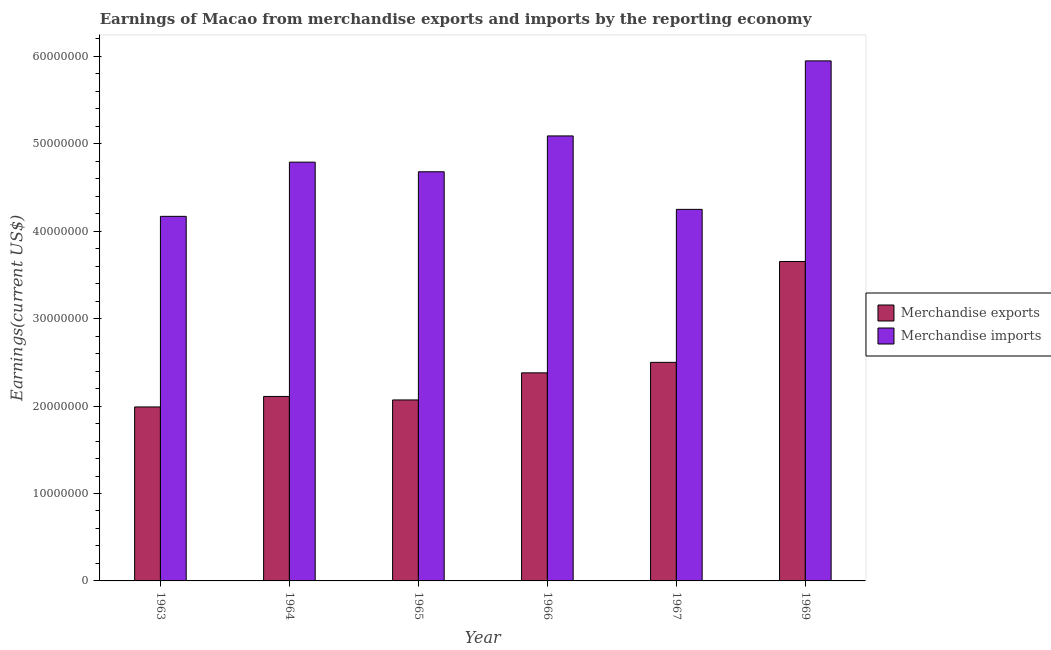How many different coloured bars are there?
Your answer should be compact. 2. How many groups of bars are there?
Offer a very short reply. 6. Are the number of bars on each tick of the X-axis equal?
Keep it short and to the point. Yes. How many bars are there on the 5th tick from the left?
Give a very brief answer. 2. What is the earnings from merchandise exports in 1964?
Your answer should be very brief. 2.11e+07. Across all years, what is the maximum earnings from merchandise exports?
Your answer should be very brief. 3.65e+07. Across all years, what is the minimum earnings from merchandise imports?
Provide a succinct answer. 4.17e+07. In which year was the earnings from merchandise exports maximum?
Give a very brief answer. 1969. In which year was the earnings from merchandise exports minimum?
Make the answer very short. 1963. What is the total earnings from merchandise exports in the graph?
Your answer should be very brief. 1.47e+08. What is the difference between the earnings from merchandise exports in 1966 and that in 1969?
Your answer should be very brief. -1.27e+07. What is the difference between the earnings from merchandise exports in 1969 and the earnings from merchandise imports in 1966?
Offer a terse response. 1.27e+07. What is the average earnings from merchandise exports per year?
Keep it short and to the point. 2.45e+07. In the year 1969, what is the difference between the earnings from merchandise imports and earnings from merchandise exports?
Your answer should be very brief. 0. In how many years, is the earnings from merchandise imports greater than 56000000 US$?
Ensure brevity in your answer.  1. What is the ratio of the earnings from merchandise imports in 1964 to that in 1969?
Provide a succinct answer. 0.81. Is the earnings from merchandise exports in 1965 less than that in 1969?
Your answer should be very brief. Yes. What is the difference between the highest and the second highest earnings from merchandise exports?
Keep it short and to the point. 1.15e+07. What is the difference between the highest and the lowest earnings from merchandise imports?
Your answer should be very brief. 1.78e+07. In how many years, is the earnings from merchandise exports greater than the average earnings from merchandise exports taken over all years?
Ensure brevity in your answer.  2. How many bars are there?
Make the answer very short. 12. Are all the bars in the graph horizontal?
Your response must be concise. No. How many years are there in the graph?
Give a very brief answer. 6. Are the values on the major ticks of Y-axis written in scientific E-notation?
Offer a terse response. No. Does the graph contain grids?
Give a very brief answer. No. Where does the legend appear in the graph?
Your response must be concise. Center right. How are the legend labels stacked?
Provide a short and direct response. Vertical. What is the title of the graph?
Ensure brevity in your answer.  Earnings of Macao from merchandise exports and imports by the reporting economy. Does "Time to export" appear as one of the legend labels in the graph?
Your answer should be compact. No. What is the label or title of the Y-axis?
Your answer should be compact. Earnings(current US$). What is the Earnings(current US$) of Merchandise exports in 1963?
Offer a very short reply. 1.99e+07. What is the Earnings(current US$) of Merchandise imports in 1963?
Provide a succinct answer. 4.17e+07. What is the Earnings(current US$) of Merchandise exports in 1964?
Your response must be concise. 2.11e+07. What is the Earnings(current US$) in Merchandise imports in 1964?
Make the answer very short. 4.79e+07. What is the Earnings(current US$) of Merchandise exports in 1965?
Your response must be concise. 2.07e+07. What is the Earnings(current US$) in Merchandise imports in 1965?
Offer a very short reply. 4.68e+07. What is the Earnings(current US$) of Merchandise exports in 1966?
Your response must be concise. 2.38e+07. What is the Earnings(current US$) in Merchandise imports in 1966?
Give a very brief answer. 5.09e+07. What is the Earnings(current US$) in Merchandise exports in 1967?
Keep it short and to the point. 2.50e+07. What is the Earnings(current US$) in Merchandise imports in 1967?
Ensure brevity in your answer.  4.25e+07. What is the Earnings(current US$) of Merchandise exports in 1969?
Provide a succinct answer. 3.65e+07. What is the Earnings(current US$) in Merchandise imports in 1969?
Ensure brevity in your answer.  5.95e+07. Across all years, what is the maximum Earnings(current US$) of Merchandise exports?
Provide a short and direct response. 3.65e+07. Across all years, what is the maximum Earnings(current US$) in Merchandise imports?
Offer a very short reply. 5.95e+07. Across all years, what is the minimum Earnings(current US$) in Merchandise exports?
Your answer should be compact. 1.99e+07. Across all years, what is the minimum Earnings(current US$) in Merchandise imports?
Provide a short and direct response. 4.17e+07. What is the total Earnings(current US$) in Merchandise exports in the graph?
Your response must be concise. 1.47e+08. What is the total Earnings(current US$) in Merchandise imports in the graph?
Give a very brief answer. 2.89e+08. What is the difference between the Earnings(current US$) of Merchandise exports in 1963 and that in 1964?
Ensure brevity in your answer.  -1.20e+06. What is the difference between the Earnings(current US$) in Merchandise imports in 1963 and that in 1964?
Your answer should be very brief. -6.20e+06. What is the difference between the Earnings(current US$) in Merchandise exports in 1963 and that in 1965?
Ensure brevity in your answer.  -8.00e+05. What is the difference between the Earnings(current US$) of Merchandise imports in 1963 and that in 1965?
Provide a short and direct response. -5.10e+06. What is the difference between the Earnings(current US$) of Merchandise exports in 1963 and that in 1966?
Offer a very short reply. -3.90e+06. What is the difference between the Earnings(current US$) of Merchandise imports in 1963 and that in 1966?
Ensure brevity in your answer.  -9.20e+06. What is the difference between the Earnings(current US$) in Merchandise exports in 1963 and that in 1967?
Ensure brevity in your answer.  -5.10e+06. What is the difference between the Earnings(current US$) of Merchandise imports in 1963 and that in 1967?
Your response must be concise. -8.00e+05. What is the difference between the Earnings(current US$) in Merchandise exports in 1963 and that in 1969?
Your answer should be very brief. -1.66e+07. What is the difference between the Earnings(current US$) in Merchandise imports in 1963 and that in 1969?
Offer a very short reply. -1.78e+07. What is the difference between the Earnings(current US$) of Merchandise imports in 1964 and that in 1965?
Provide a short and direct response. 1.10e+06. What is the difference between the Earnings(current US$) in Merchandise exports in 1964 and that in 1966?
Your answer should be compact. -2.70e+06. What is the difference between the Earnings(current US$) in Merchandise exports in 1964 and that in 1967?
Keep it short and to the point. -3.90e+06. What is the difference between the Earnings(current US$) in Merchandise imports in 1964 and that in 1967?
Your answer should be very brief. 5.40e+06. What is the difference between the Earnings(current US$) of Merchandise exports in 1964 and that in 1969?
Provide a succinct answer. -1.54e+07. What is the difference between the Earnings(current US$) in Merchandise imports in 1964 and that in 1969?
Your answer should be compact. -1.16e+07. What is the difference between the Earnings(current US$) of Merchandise exports in 1965 and that in 1966?
Your response must be concise. -3.10e+06. What is the difference between the Earnings(current US$) of Merchandise imports in 1965 and that in 1966?
Make the answer very short. -4.10e+06. What is the difference between the Earnings(current US$) of Merchandise exports in 1965 and that in 1967?
Give a very brief answer. -4.30e+06. What is the difference between the Earnings(current US$) in Merchandise imports in 1965 and that in 1967?
Offer a very short reply. 4.30e+06. What is the difference between the Earnings(current US$) of Merchandise exports in 1965 and that in 1969?
Make the answer very short. -1.58e+07. What is the difference between the Earnings(current US$) of Merchandise imports in 1965 and that in 1969?
Make the answer very short. -1.27e+07. What is the difference between the Earnings(current US$) of Merchandise exports in 1966 and that in 1967?
Give a very brief answer. -1.20e+06. What is the difference between the Earnings(current US$) in Merchandise imports in 1966 and that in 1967?
Ensure brevity in your answer.  8.40e+06. What is the difference between the Earnings(current US$) in Merchandise exports in 1966 and that in 1969?
Your answer should be very brief. -1.27e+07. What is the difference between the Earnings(current US$) in Merchandise imports in 1966 and that in 1969?
Provide a short and direct response. -8.58e+06. What is the difference between the Earnings(current US$) in Merchandise exports in 1967 and that in 1969?
Make the answer very short. -1.15e+07. What is the difference between the Earnings(current US$) in Merchandise imports in 1967 and that in 1969?
Your answer should be very brief. -1.70e+07. What is the difference between the Earnings(current US$) in Merchandise exports in 1963 and the Earnings(current US$) in Merchandise imports in 1964?
Your answer should be very brief. -2.80e+07. What is the difference between the Earnings(current US$) of Merchandise exports in 1963 and the Earnings(current US$) of Merchandise imports in 1965?
Your answer should be very brief. -2.69e+07. What is the difference between the Earnings(current US$) of Merchandise exports in 1963 and the Earnings(current US$) of Merchandise imports in 1966?
Make the answer very short. -3.10e+07. What is the difference between the Earnings(current US$) in Merchandise exports in 1963 and the Earnings(current US$) in Merchandise imports in 1967?
Your answer should be very brief. -2.26e+07. What is the difference between the Earnings(current US$) in Merchandise exports in 1963 and the Earnings(current US$) in Merchandise imports in 1969?
Give a very brief answer. -3.96e+07. What is the difference between the Earnings(current US$) of Merchandise exports in 1964 and the Earnings(current US$) of Merchandise imports in 1965?
Provide a succinct answer. -2.57e+07. What is the difference between the Earnings(current US$) in Merchandise exports in 1964 and the Earnings(current US$) in Merchandise imports in 1966?
Provide a succinct answer. -2.98e+07. What is the difference between the Earnings(current US$) of Merchandise exports in 1964 and the Earnings(current US$) of Merchandise imports in 1967?
Offer a very short reply. -2.14e+07. What is the difference between the Earnings(current US$) of Merchandise exports in 1964 and the Earnings(current US$) of Merchandise imports in 1969?
Offer a very short reply. -3.84e+07. What is the difference between the Earnings(current US$) of Merchandise exports in 1965 and the Earnings(current US$) of Merchandise imports in 1966?
Provide a short and direct response. -3.02e+07. What is the difference between the Earnings(current US$) of Merchandise exports in 1965 and the Earnings(current US$) of Merchandise imports in 1967?
Your answer should be compact. -2.18e+07. What is the difference between the Earnings(current US$) of Merchandise exports in 1965 and the Earnings(current US$) of Merchandise imports in 1969?
Your answer should be compact. -3.88e+07. What is the difference between the Earnings(current US$) of Merchandise exports in 1966 and the Earnings(current US$) of Merchandise imports in 1967?
Provide a short and direct response. -1.87e+07. What is the difference between the Earnings(current US$) in Merchandise exports in 1966 and the Earnings(current US$) in Merchandise imports in 1969?
Make the answer very short. -3.57e+07. What is the difference between the Earnings(current US$) of Merchandise exports in 1967 and the Earnings(current US$) of Merchandise imports in 1969?
Keep it short and to the point. -3.45e+07. What is the average Earnings(current US$) in Merchandise exports per year?
Your answer should be compact. 2.45e+07. What is the average Earnings(current US$) of Merchandise imports per year?
Provide a short and direct response. 4.82e+07. In the year 1963, what is the difference between the Earnings(current US$) in Merchandise exports and Earnings(current US$) in Merchandise imports?
Provide a succinct answer. -2.18e+07. In the year 1964, what is the difference between the Earnings(current US$) in Merchandise exports and Earnings(current US$) in Merchandise imports?
Your answer should be very brief. -2.68e+07. In the year 1965, what is the difference between the Earnings(current US$) of Merchandise exports and Earnings(current US$) of Merchandise imports?
Ensure brevity in your answer.  -2.61e+07. In the year 1966, what is the difference between the Earnings(current US$) of Merchandise exports and Earnings(current US$) of Merchandise imports?
Offer a terse response. -2.71e+07. In the year 1967, what is the difference between the Earnings(current US$) of Merchandise exports and Earnings(current US$) of Merchandise imports?
Give a very brief answer. -1.75e+07. In the year 1969, what is the difference between the Earnings(current US$) of Merchandise exports and Earnings(current US$) of Merchandise imports?
Provide a short and direct response. -2.29e+07. What is the ratio of the Earnings(current US$) of Merchandise exports in 1963 to that in 1964?
Provide a short and direct response. 0.94. What is the ratio of the Earnings(current US$) in Merchandise imports in 1963 to that in 1964?
Ensure brevity in your answer.  0.87. What is the ratio of the Earnings(current US$) of Merchandise exports in 1963 to that in 1965?
Give a very brief answer. 0.96. What is the ratio of the Earnings(current US$) in Merchandise imports in 1963 to that in 1965?
Your response must be concise. 0.89. What is the ratio of the Earnings(current US$) in Merchandise exports in 1963 to that in 1966?
Your answer should be compact. 0.84. What is the ratio of the Earnings(current US$) of Merchandise imports in 1963 to that in 1966?
Keep it short and to the point. 0.82. What is the ratio of the Earnings(current US$) of Merchandise exports in 1963 to that in 1967?
Keep it short and to the point. 0.8. What is the ratio of the Earnings(current US$) of Merchandise imports in 1963 to that in 1967?
Give a very brief answer. 0.98. What is the ratio of the Earnings(current US$) of Merchandise exports in 1963 to that in 1969?
Offer a terse response. 0.54. What is the ratio of the Earnings(current US$) in Merchandise imports in 1963 to that in 1969?
Keep it short and to the point. 0.7. What is the ratio of the Earnings(current US$) in Merchandise exports in 1964 to that in 1965?
Give a very brief answer. 1.02. What is the ratio of the Earnings(current US$) of Merchandise imports in 1964 to that in 1965?
Keep it short and to the point. 1.02. What is the ratio of the Earnings(current US$) of Merchandise exports in 1964 to that in 1966?
Keep it short and to the point. 0.89. What is the ratio of the Earnings(current US$) in Merchandise imports in 1964 to that in 1966?
Offer a very short reply. 0.94. What is the ratio of the Earnings(current US$) in Merchandise exports in 1964 to that in 1967?
Offer a very short reply. 0.84. What is the ratio of the Earnings(current US$) in Merchandise imports in 1964 to that in 1967?
Your answer should be compact. 1.13. What is the ratio of the Earnings(current US$) in Merchandise exports in 1964 to that in 1969?
Keep it short and to the point. 0.58. What is the ratio of the Earnings(current US$) in Merchandise imports in 1964 to that in 1969?
Your answer should be very brief. 0.81. What is the ratio of the Earnings(current US$) in Merchandise exports in 1965 to that in 1966?
Ensure brevity in your answer.  0.87. What is the ratio of the Earnings(current US$) in Merchandise imports in 1965 to that in 1966?
Your answer should be compact. 0.92. What is the ratio of the Earnings(current US$) in Merchandise exports in 1965 to that in 1967?
Your response must be concise. 0.83. What is the ratio of the Earnings(current US$) of Merchandise imports in 1965 to that in 1967?
Your answer should be compact. 1.1. What is the ratio of the Earnings(current US$) in Merchandise exports in 1965 to that in 1969?
Offer a very short reply. 0.57. What is the ratio of the Earnings(current US$) of Merchandise imports in 1965 to that in 1969?
Provide a short and direct response. 0.79. What is the ratio of the Earnings(current US$) in Merchandise exports in 1966 to that in 1967?
Your response must be concise. 0.95. What is the ratio of the Earnings(current US$) of Merchandise imports in 1966 to that in 1967?
Your answer should be very brief. 1.2. What is the ratio of the Earnings(current US$) of Merchandise exports in 1966 to that in 1969?
Give a very brief answer. 0.65. What is the ratio of the Earnings(current US$) of Merchandise imports in 1966 to that in 1969?
Offer a terse response. 0.86. What is the ratio of the Earnings(current US$) in Merchandise exports in 1967 to that in 1969?
Offer a very short reply. 0.68. What is the ratio of the Earnings(current US$) of Merchandise imports in 1967 to that in 1969?
Give a very brief answer. 0.71. What is the difference between the highest and the second highest Earnings(current US$) in Merchandise exports?
Ensure brevity in your answer.  1.15e+07. What is the difference between the highest and the second highest Earnings(current US$) of Merchandise imports?
Provide a short and direct response. 8.58e+06. What is the difference between the highest and the lowest Earnings(current US$) of Merchandise exports?
Keep it short and to the point. 1.66e+07. What is the difference between the highest and the lowest Earnings(current US$) of Merchandise imports?
Give a very brief answer. 1.78e+07. 